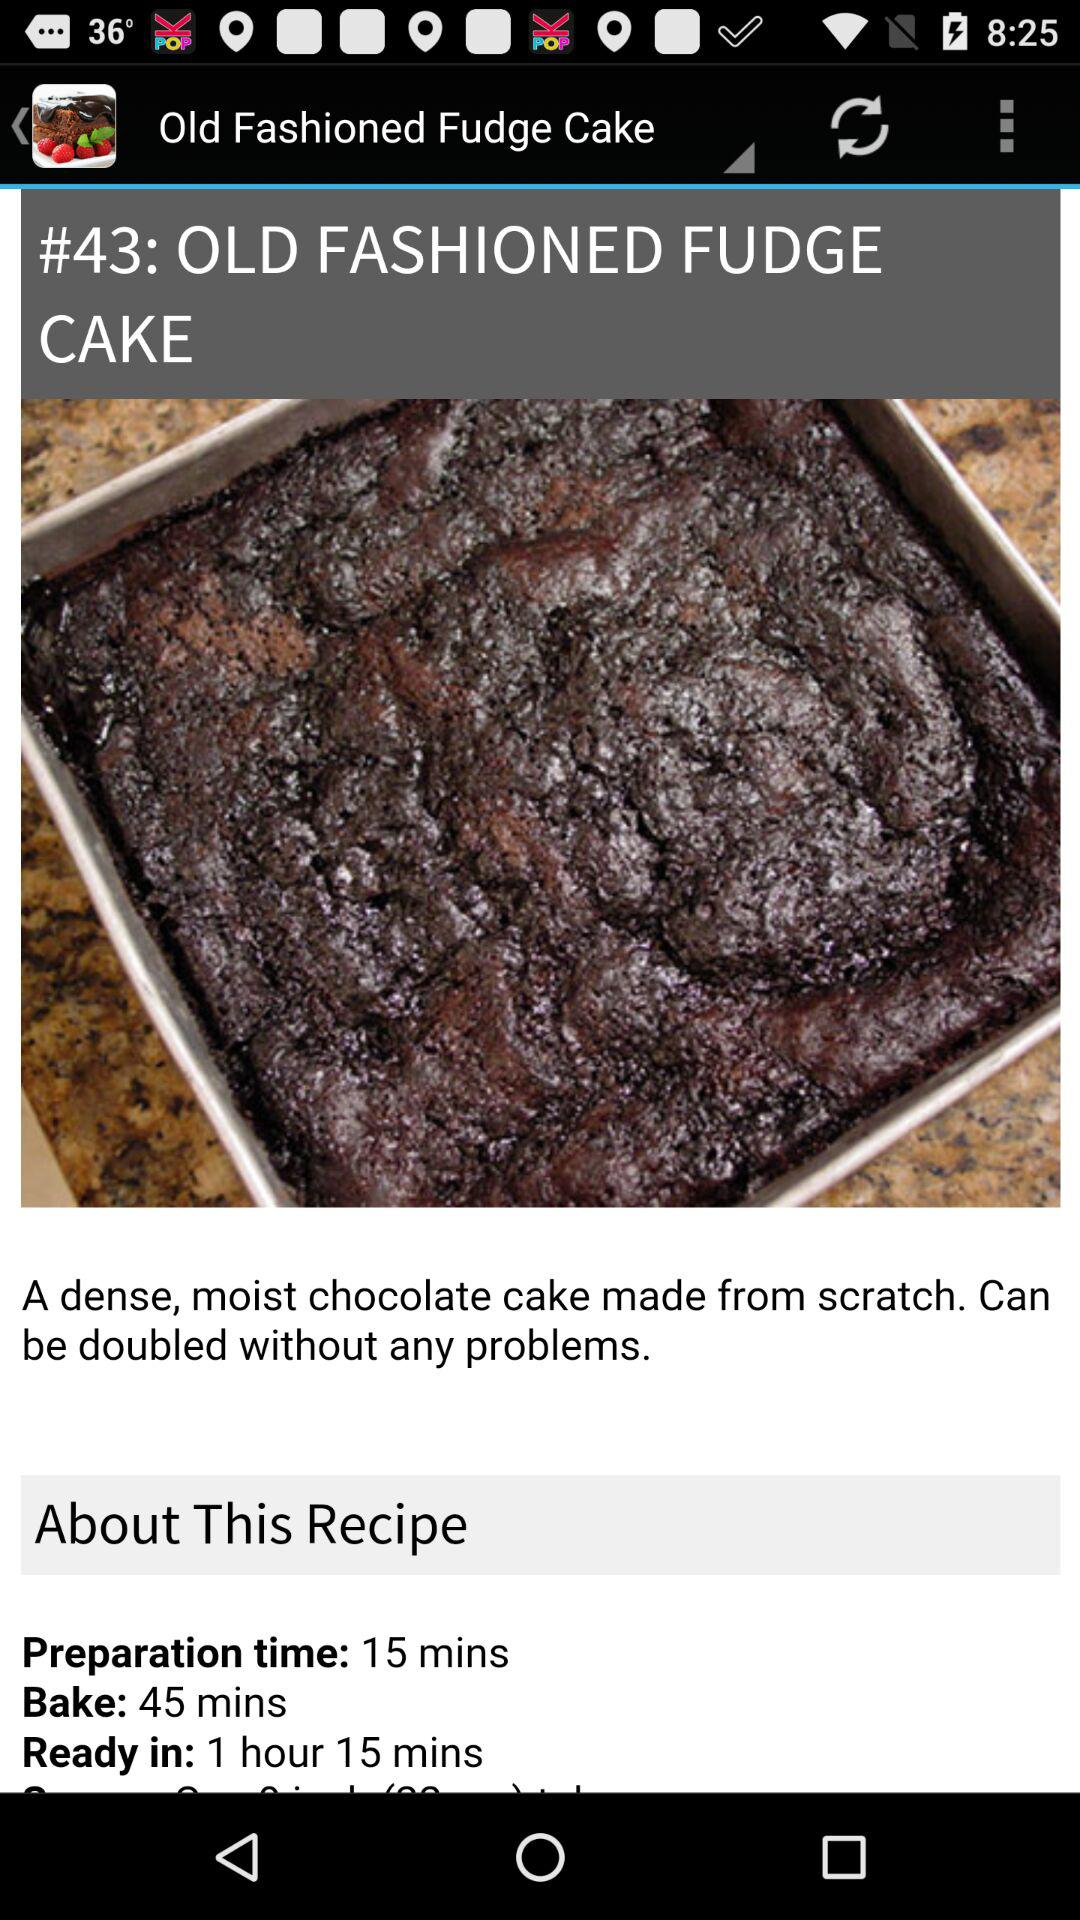What is the preparation time for making "OLD FASHIONED FUDGE CAKE"? The preparation time is 15 minutes. 